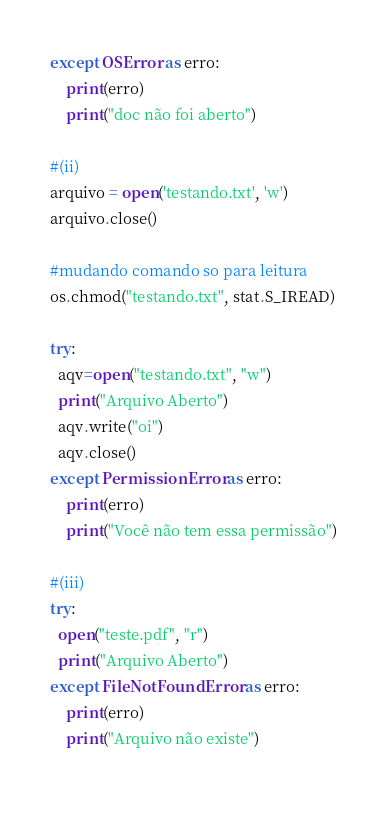<code> <loc_0><loc_0><loc_500><loc_500><_Python_>except OSError as erro:
    print(erro)
    print("doc não foi aberto")

#(ii)
arquivo = open('testando.txt', 'w')
arquivo.close()

#mudando comando so para leitura
os.chmod("testando.txt", stat.S_IREAD)

try:
  aqv=open("testando.txt", "w")
  print("Arquivo Aberto")
  aqv.write("oi")
  aqv.close()
except PermissionError as erro:
    print(erro)
    print("Você não tem essa permissão")

#(iii)
try:
  open("teste.pdf", "r")
  print("Arquivo Aberto")
except FileNotFoundError as erro:
    print(erro)
    print("Arquivo não existe")
 </code> 